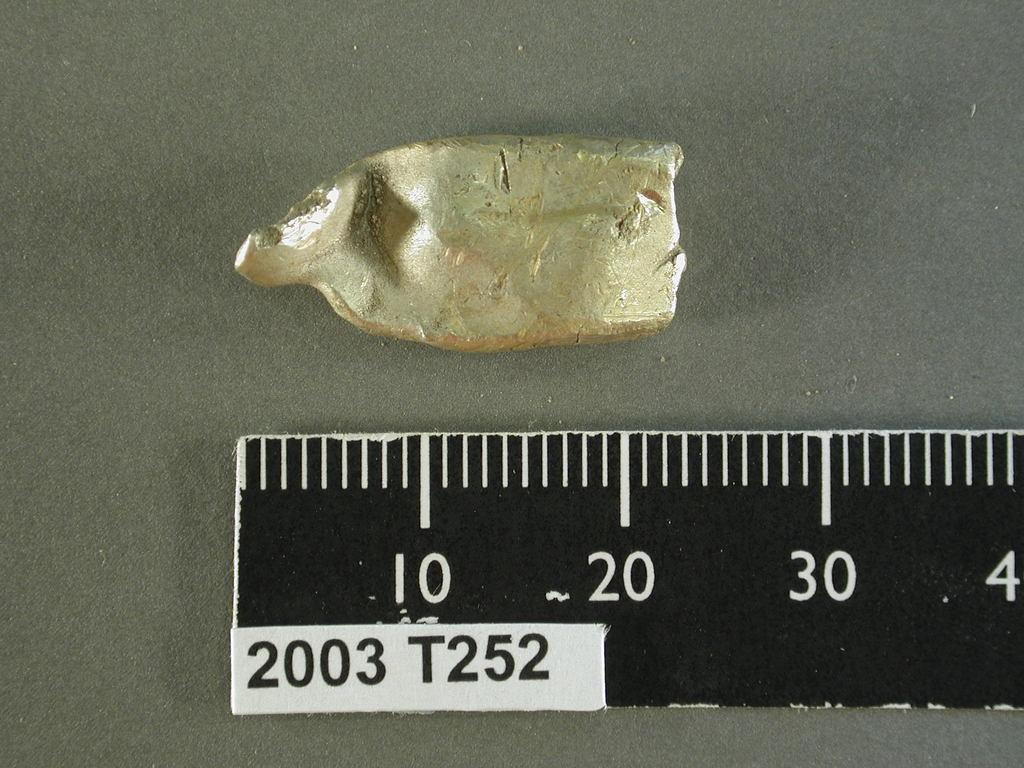What is the main object in the image? There is a scale in the image. Can you describe the object in more detail? The scale appears to have a platform and a display for measuring weight. Is there anything else in the image besides the scale? Yes, there is an object in the image. What type of stitch is being used to sew the button onto the object in the image? There is no button or stitching present in the image; it only features a scale and an unspecified object. 